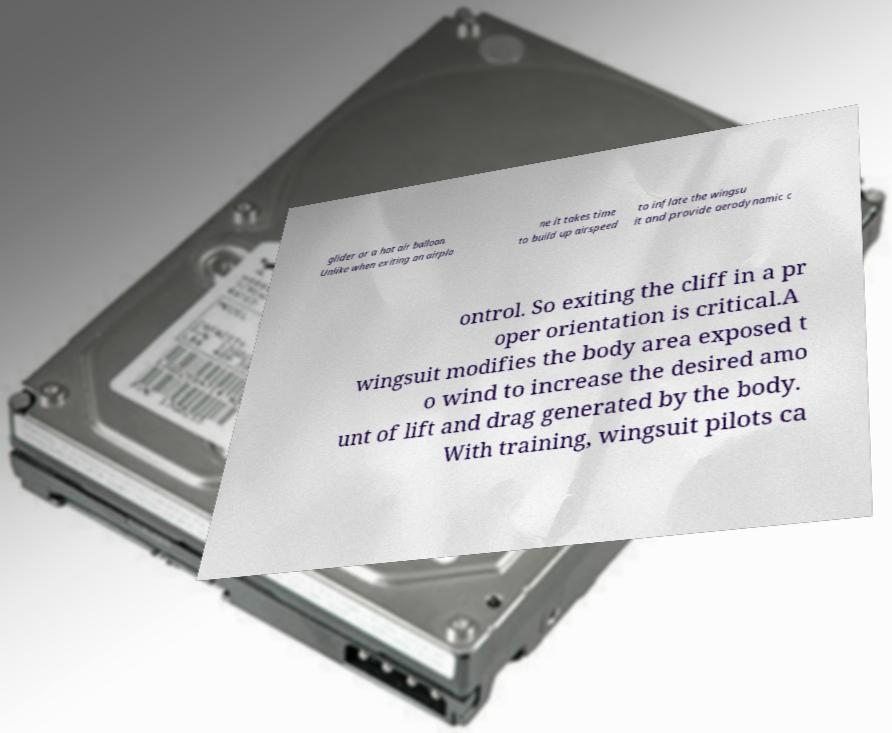I need the written content from this picture converted into text. Can you do that? glider or a hot air balloon. Unlike when exiting an airpla ne it takes time to build up airspeed to inflate the wingsu it and provide aerodynamic c ontrol. So exiting the cliff in a pr oper orientation is critical.A wingsuit modifies the body area exposed t o wind to increase the desired amo unt of lift and drag generated by the body. With training, wingsuit pilots ca 